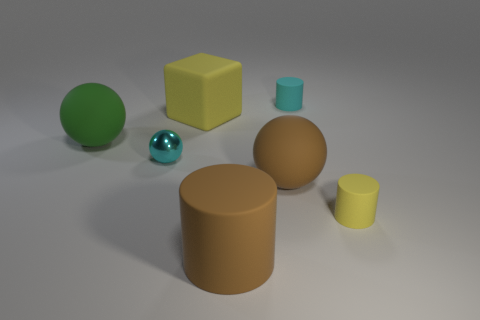Can we deduce the light source direction in this scene? Yes, we can infer the direction of the light source based on the shadows and highlights visible in the scene. The shadows extend primarily towards the lower right-hand corner of the image. This suggests that the light source is coming from the top left-hand side, casting shadows diagonally across the surfaces beneath each object. 